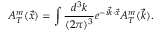Convert formula to latex. <formula><loc_0><loc_0><loc_500><loc_500>A _ { T } ^ { m } ( \vec { x } ) = \int \frac { d ^ { 3 } k } { ( 2 \pi ) ^ { 3 } } e ^ { - i \vec { k } \cdot \vec { x } } A _ { T } ^ { m } ( \vec { k } ) .</formula> 